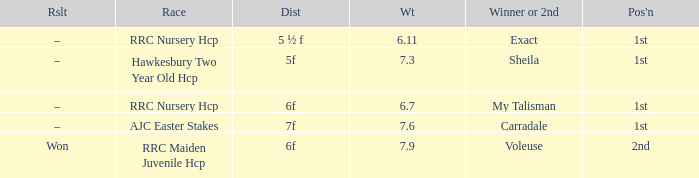What was the distance when the weight was 6.11? 5 ½ f. 